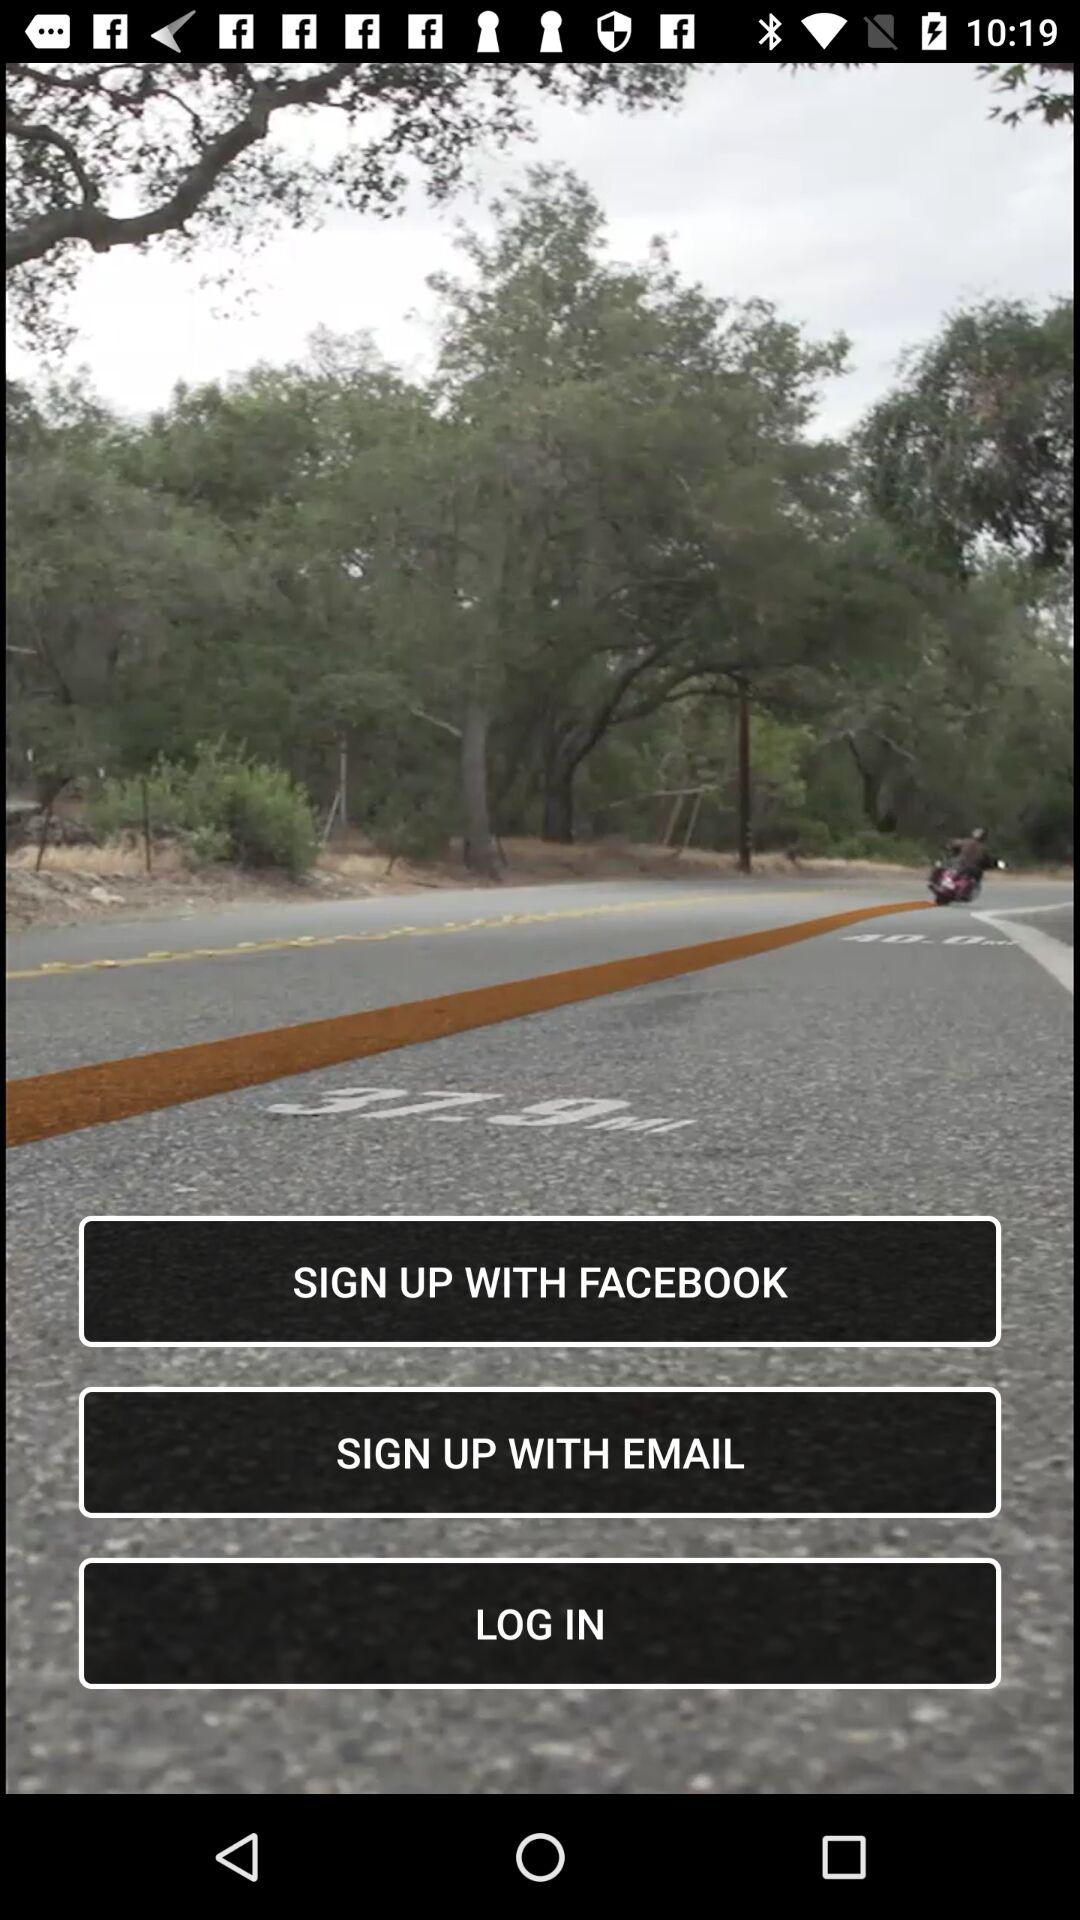How long does it take to log in?
When the provided information is insufficient, respond with <no answer>. <no answer> 